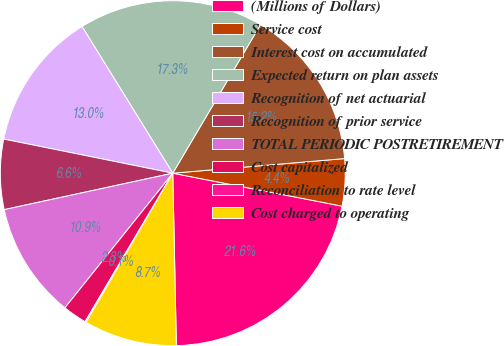Convert chart. <chart><loc_0><loc_0><loc_500><loc_500><pie_chart><fcel>(Millions of Dollars)<fcel>Service cost<fcel>Interest cost on accumulated<fcel>Expected return on plan assets<fcel>Recognition of net actuarial<fcel>Recognition of prior service<fcel>TOTAL PERIODIC POSTRETIREMENT<fcel>Cost capitalized<fcel>Reconciliation to rate level<fcel>Cost charged to operating<nl><fcel>21.61%<fcel>4.41%<fcel>15.16%<fcel>17.31%<fcel>13.01%<fcel>6.56%<fcel>10.86%<fcel>2.26%<fcel>0.11%<fcel>8.71%<nl></chart> 